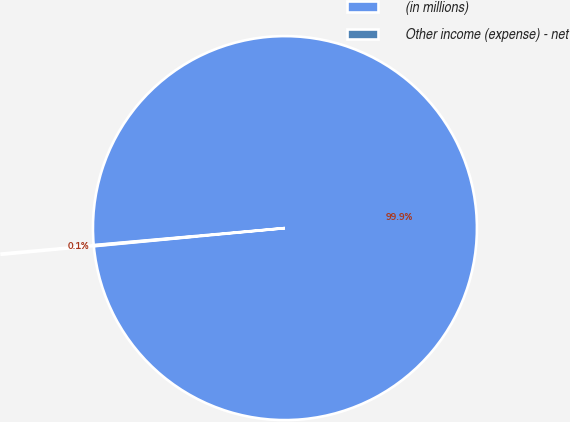<chart> <loc_0><loc_0><loc_500><loc_500><pie_chart><fcel>(in millions)<fcel>Other income (expense) - net<nl><fcel>99.9%<fcel>0.1%<nl></chart> 